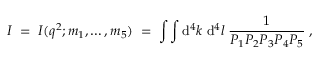<formula> <loc_0><loc_0><loc_500><loc_500>I \, = \, I ( q ^ { 2 } ; m _ { 1 } , \dots , m _ { 5 } ) \, = \, \int \int d ^ { 4 } k \, d ^ { 4 } l \, \frac { 1 } { P _ { 1 } P _ { 2 } P _ { 3 } P _ { 4 } P _ { 5 } } \, ,</formula> 